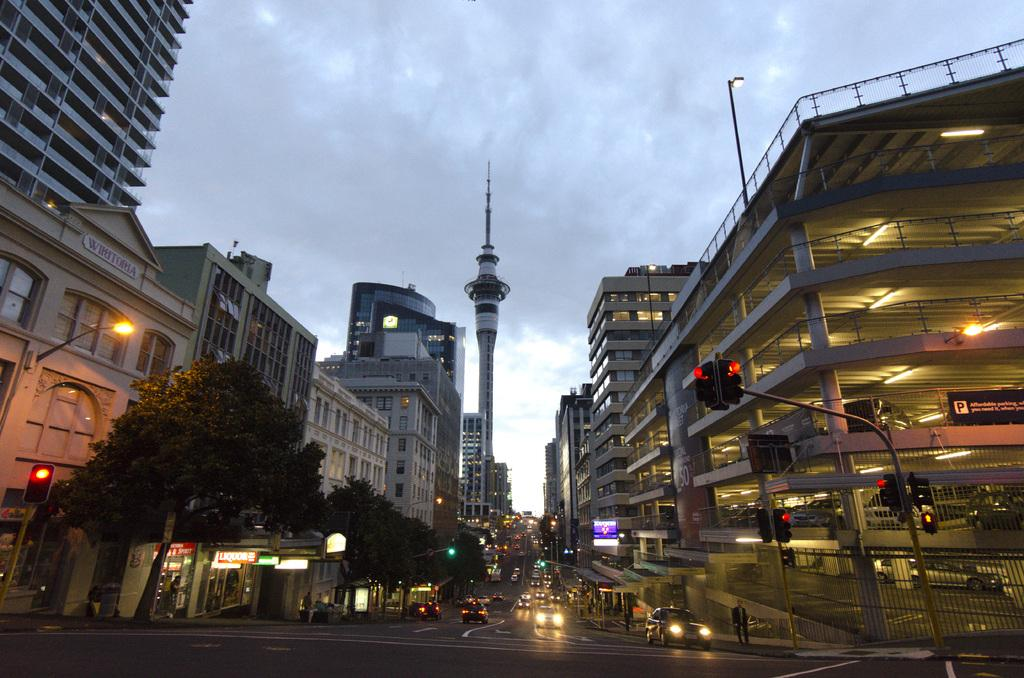What type of structures can be seen in the image? There are buildings in the image. What other natural elements are present in the image? There are trees in the image. What types of man-made objects can be seen in the image? There are vehicles and poles in the image. Are there any people visible in the image? Yes, there are persons in the image. What is the condition of the sky in the image? The sky is cloudy in the image. What is located in the background of the image? There is a tower in the background of the image. What type of rule is being enforced by the jar in the image? There is no jar present in the image, and therefore no rule is being enforced. What part of the tower is visible in the image? The tower is located in the background of the image, and only a portion of it is visible. However, the specific part cannot be determined from the provided facts. 